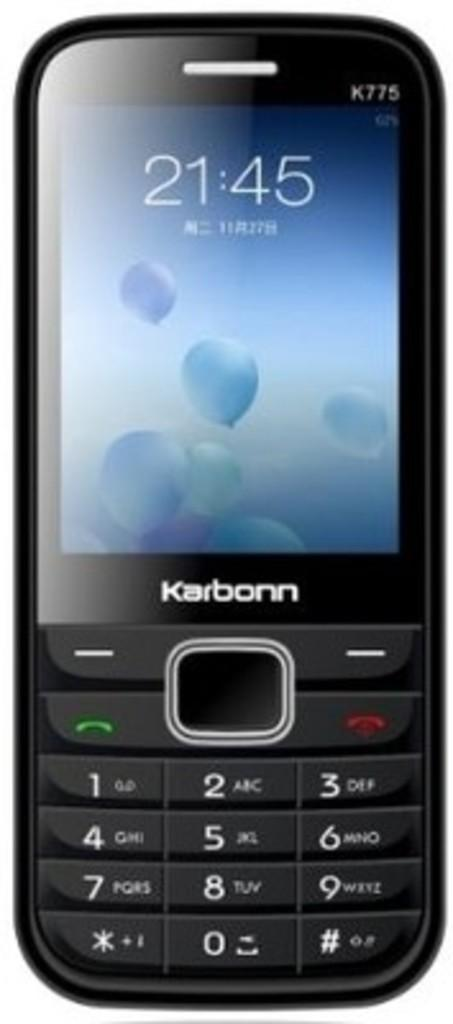<image>
Summarize the visual content of the image. a karbonn k775 cell phone time set at 21:45 